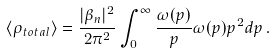Convert formula to latex. <formula><loc_0><loc_0><loc_500><loc_500>\langle \rho _ { t o t a l } \rangle = \frac { | \beta _ { n } | ^ { 2 } } { 2 \pi ^ { 2 } } \int ^ { \infty } _ { 0 } \frac { \omega ( p ) } { p } \omega ( p ) p ^ { 2 } d p \, .</formula> 